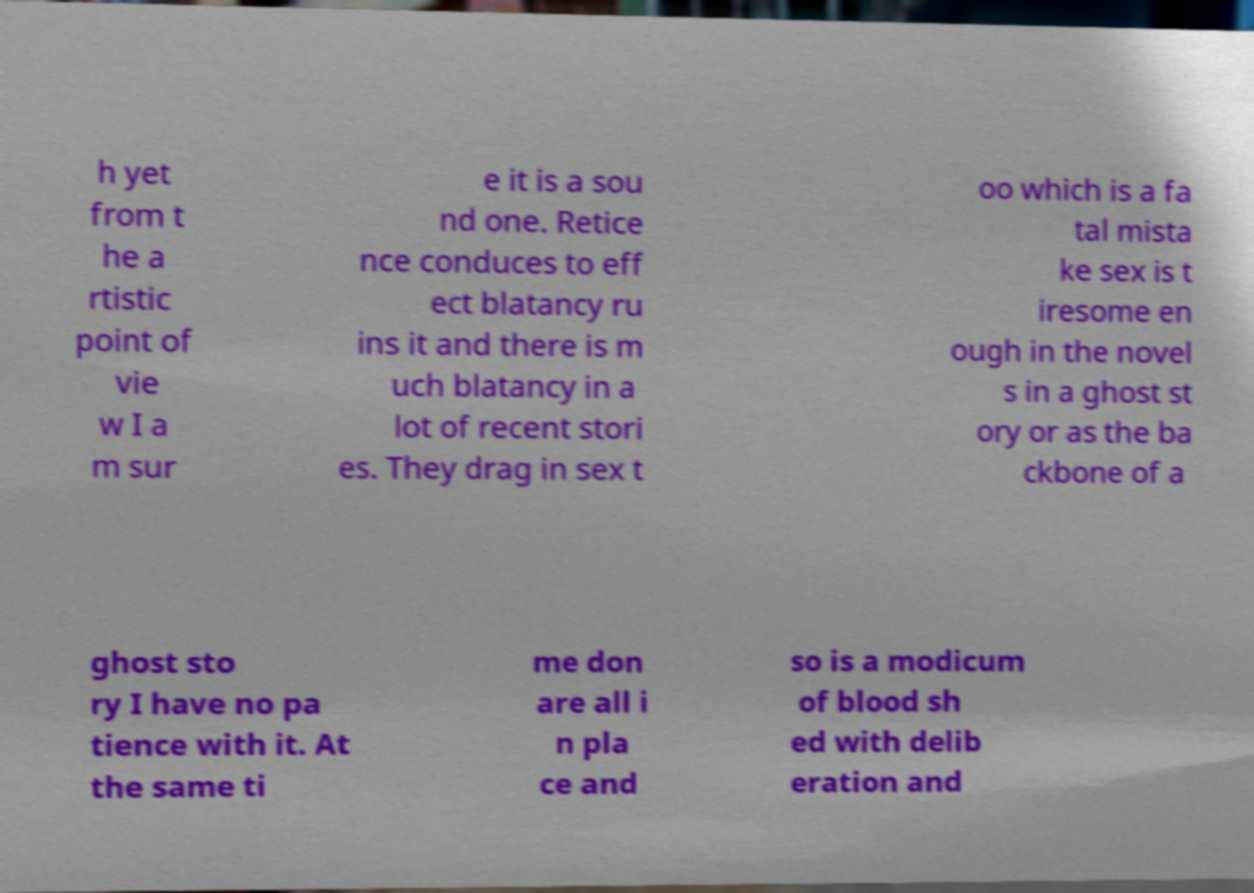Please read and relay the text visible in this image. What does it say? h yet from t he a rtistic point of vie w I a m sur e it is a sou nd one. Retice nce conduces to eff ect blatancy ru ins it and there is m uch blatancy in a lot of recent stori es. They drag in sex t oo which is a fa tal mista ke sex is t iresome en ough in the novel s in a ghost st ory or as the ba ckbone of a ghost sto ry I have no pa tience with it. At the same ti me don are all i n pla ce and so is a modicum of blood sh ed with delib eration and 